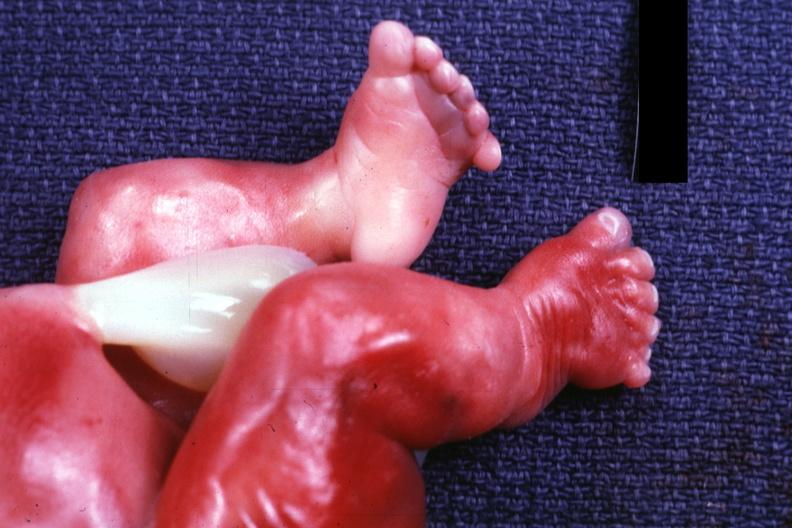s normal newborn present?
Answer the question using a single word or phrase. No 